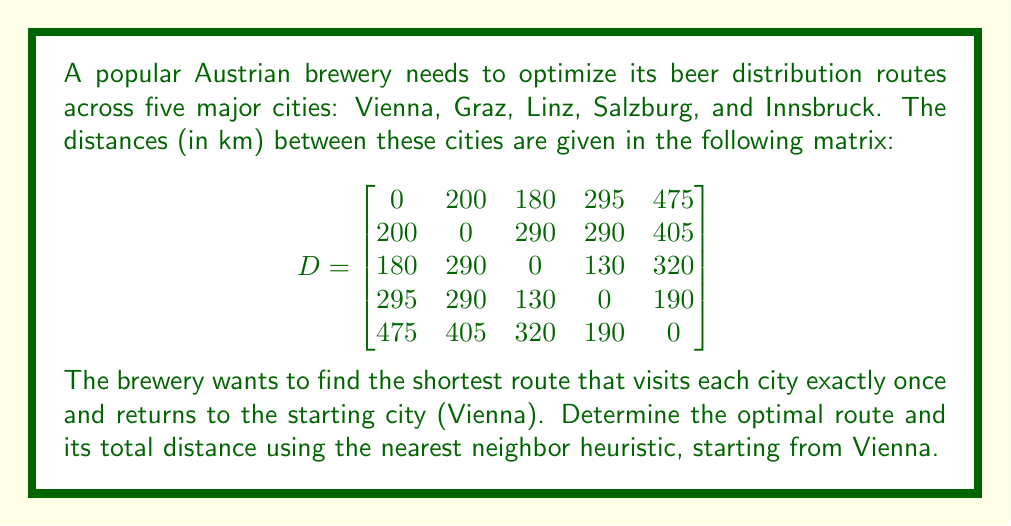Give your solution to this math problem. Let's solve this problem using the nearest neighbor heuristic:

1. Start in Vienna (V).

2. Find the nearest unvisited city to Vienna:
   - Graz: 200 km
   - Linz: 180 km (nearest)
   - Salzburg: 295 km
   - Innsbruck: 475 km
   
   Add Linz to the route: V → L

3. From Linz, find the nearest unvisited city:
   - Graz: 290 km
   - Salzburg: 130 km (nearest)
   - Innsbruck: 320 km
   
   Add Salzburg to the route: V → L → S

4. From Salzburg, find the nearest unvisited city:
   - Graz: 290 km
   - Innsbruck: 190 km (nearest)
   
   Add Innsbruck to the route: V → L → S → I

5. The only unvisited city is Graz, so add it to the route:
   V → L → S → I → G

6. Return to Vienna to complete the tour:
   V → L → S → I → G → V

7. Calculate the total distance:
   $$(180 + 130 + 190 + 405 + 200) = 1105 \text{ km}$$

The nearest neighbor heuristic doesn't guarantee the optimal solution, but it provides a good approximation.
Answer: The optimal route using the nearest neighbor heuristic is:
Vienna → Linz → Salzburg → Innsbruck → Graz → Vienna

Total distance: 1105 km 